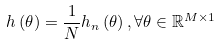Convert formula to latex. <formula><loc_0><loc_0><loc_500><loc_500>h \left ( \theta \right ) = \frac { 1 } { N } h _ { n } \left ( \theta \right ) , \forall \theta \in \mathbb { R } ^ { M \times 1 }</formula> 